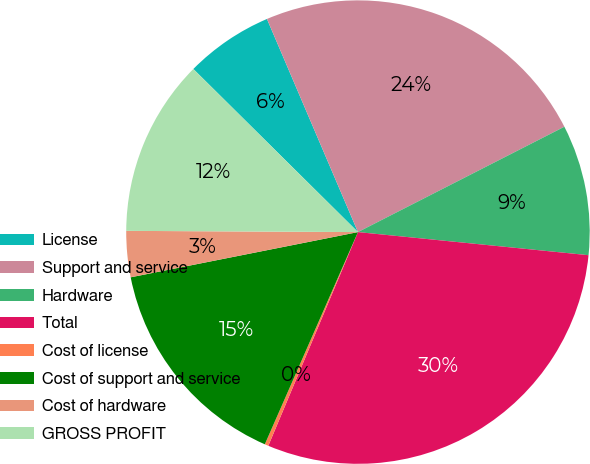Convert chart. <chart><loc_0><loc_0><loc_500><loc_500><pie_chart><fcel>License<fcel>Support and service<fcel>Hardware<fcel>Total<fcel>Cost of license<fcel>Cost of support and service<fcel>Cost of hardware<fcel>GROSS PROFIT<nl><fcel>6.15%<fcel>23.91%<fcel>9.1%<fcel>29.73%<fcel>0.26%<fcel>15.29%<fcel>3.21%<fcel>12.34%<nl></chart> 